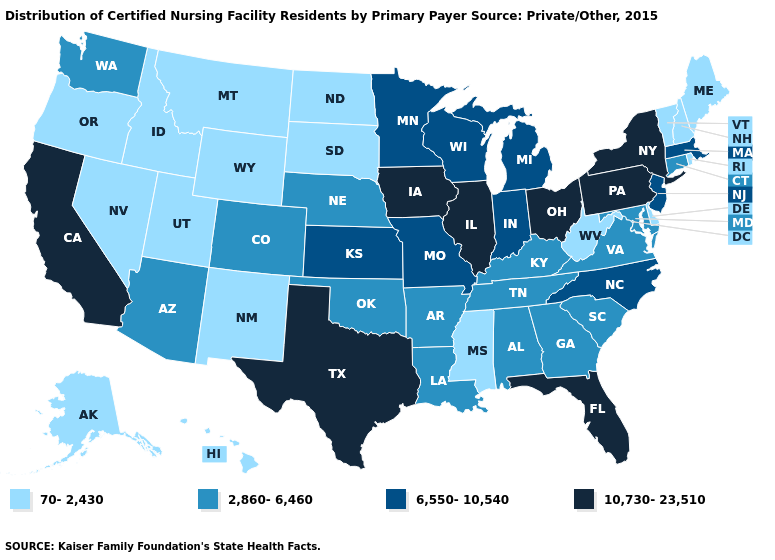What is the value of Nebraska?
Quick response, please. 2,860-6,460. What is the value of New Jersey?
Quick response, please. 6,550-10,540. Is the legend a continuous bar?
Short answer required. No. What is the lowest value in the MidWest?
Write a very short answer. 70-2,430. Which states have the lowest value in the USA?
Keep it brief. Alaska, Delaware, Hawaii, Idaho, Maine, Mississippi, Montana, Nevada, New Hampshire, New Mexico, North Dakota, Oregon, Rhode Island, South Dakota, Utah, Vermont, West Virginia, Wyoming. What is the value of Mississippi?
Short answer required. 70-2,430. What is the highest value in the MidWest ?
Short answer required. 10,730-23,510. Name the states that have a value in the range 70-2,430?
Quick response, please. Alaska, Delaware, Hawaii, Idaho, Maine, Mississippi, Montana, Nevada, New Hampshire, New Mexico, North Dakota, Oregon, Rhode Island, South Dakota, Utah, Vermont, West Virginia, Wyoming. What is the highest value in the South ?
Quick response, please. 10,730-23,510. What is the value of Oregon?
Give a very brief answer. 70-2,430. Name the states that have a value in the range 10,730-23,510?
Answer briefly. California, Florida, Illinois, Iowa, New York, Ohio, Pennsylvania, Texas. Does the map have missing data?
Be succinct. No. How many symbols are there in the legend?
Keep it brief. 4. Name the states that have a value in the range 6,550-10,540?
Give a very brief answer. Indiana, Kansas, Massachusetts, Michigan, Minnesota, Missouri, New Jersey, North Carolina, Wisconsin. 